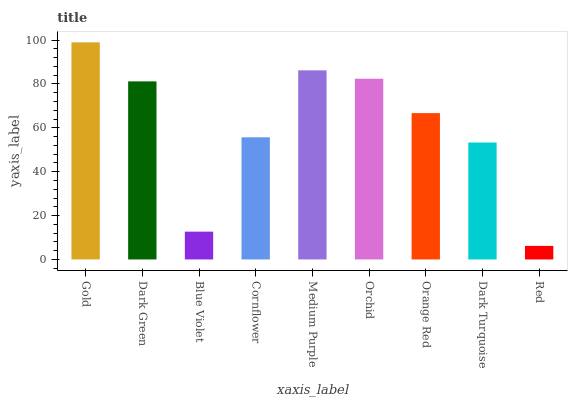Is Dark Green the minimum?
Answer yes or no. No. Is Dark Green the maximum?
Answer yes or no. No. Is Gold greater than Dark Green?
Answer yes or no. Yes. Is Dark Green less than Gold?
Answer yes or no. Yes. Is Dark Green greater than Gold?
Answer yes or no. No. Is Gold less than Dark Green?
Answer yes or no. No. Is Orange Red the high median?
Answer yes or no. Yes. Is Orange Red the low median?
Answer yes or no. Yes. Is Dark Turquoise the high median?
Answer yes or no. No. Is Gold the low median?
Answer yes or no. No. 